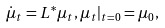Convert formula to latex. <formula><loc_0><loc_0><loc_500><loc_500>\dot { \mu } _ { t } = L ^ { * } \mu _ { t } , \mu _ { t } | _ { t = 0 } = \mu _ { 0 } ,</formula> 